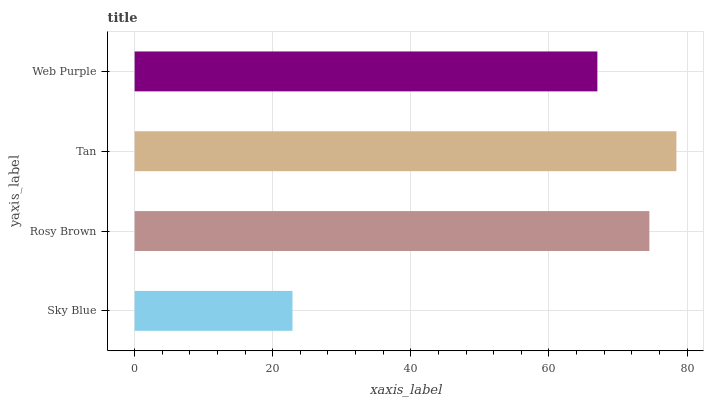Is Sky Blue the minimum?
Answer yes or no. Yes. Is Tan the maximum?
Answer yes or no. Yes. Is Rosy Brown the minimum?
Answer yes or no. No. Is Rosy Brown the maximum?
Answer yes or no. No. Is Rosy Brown greater than Sky Blue?
Answer yes or no. Yes. Is Sky Blue less than Rosy Brown?
Answer yes or no. Yes. Is Sky Blue greater than Rosy Brown?
Answer yes or no. No. Is Rosy Brown less than Sky Blue?
Answer yes or no. No. Is Rosy Brown the high median?
Answer yes or no. Yes. Is Web Purple the low median?
Answer yes or no. Yes. Is Web Purple the high median?
Answer yes or no. No. Is Rosy Brown the low median?
Answer yes or no. No. 